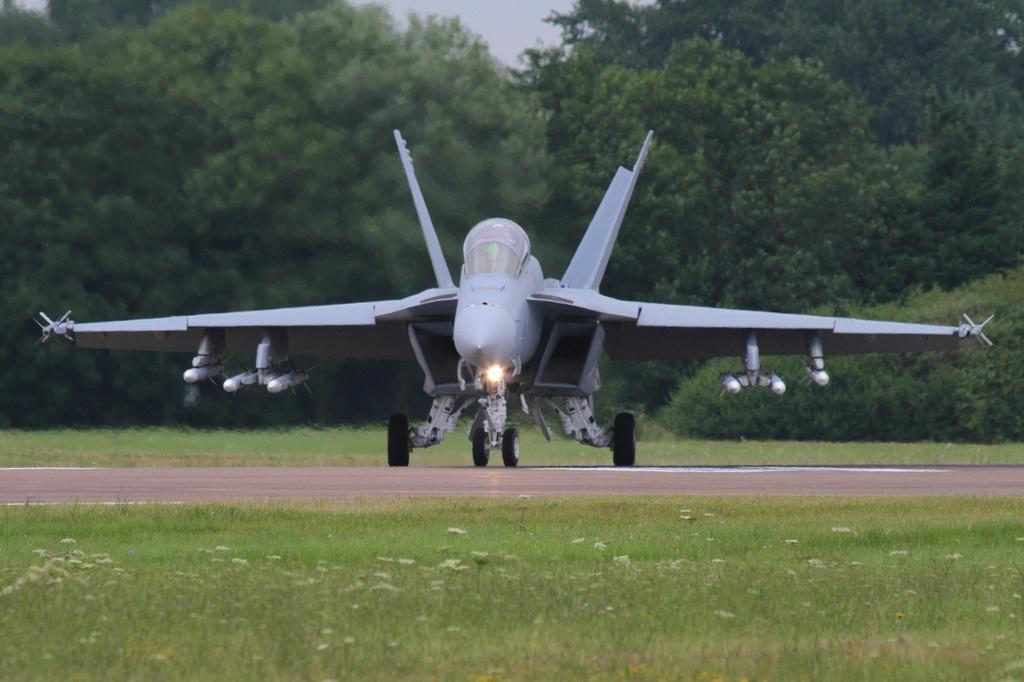What is located on the runway in the image? There is an airplane on the runway in the image. What can be seen in the background of the image? There are trees in the background of the image. What type of vegetation is present on both sides of the runway? There is grass on both sides of the runway. What type of yarn is being used by the laborer in the image? There is no laborer or yarn present in the image. How many bushes are visible in the image? There are no bushes visible in the image; it features an airplane on the runway with trees in the background and grass on both sides of the runway. 